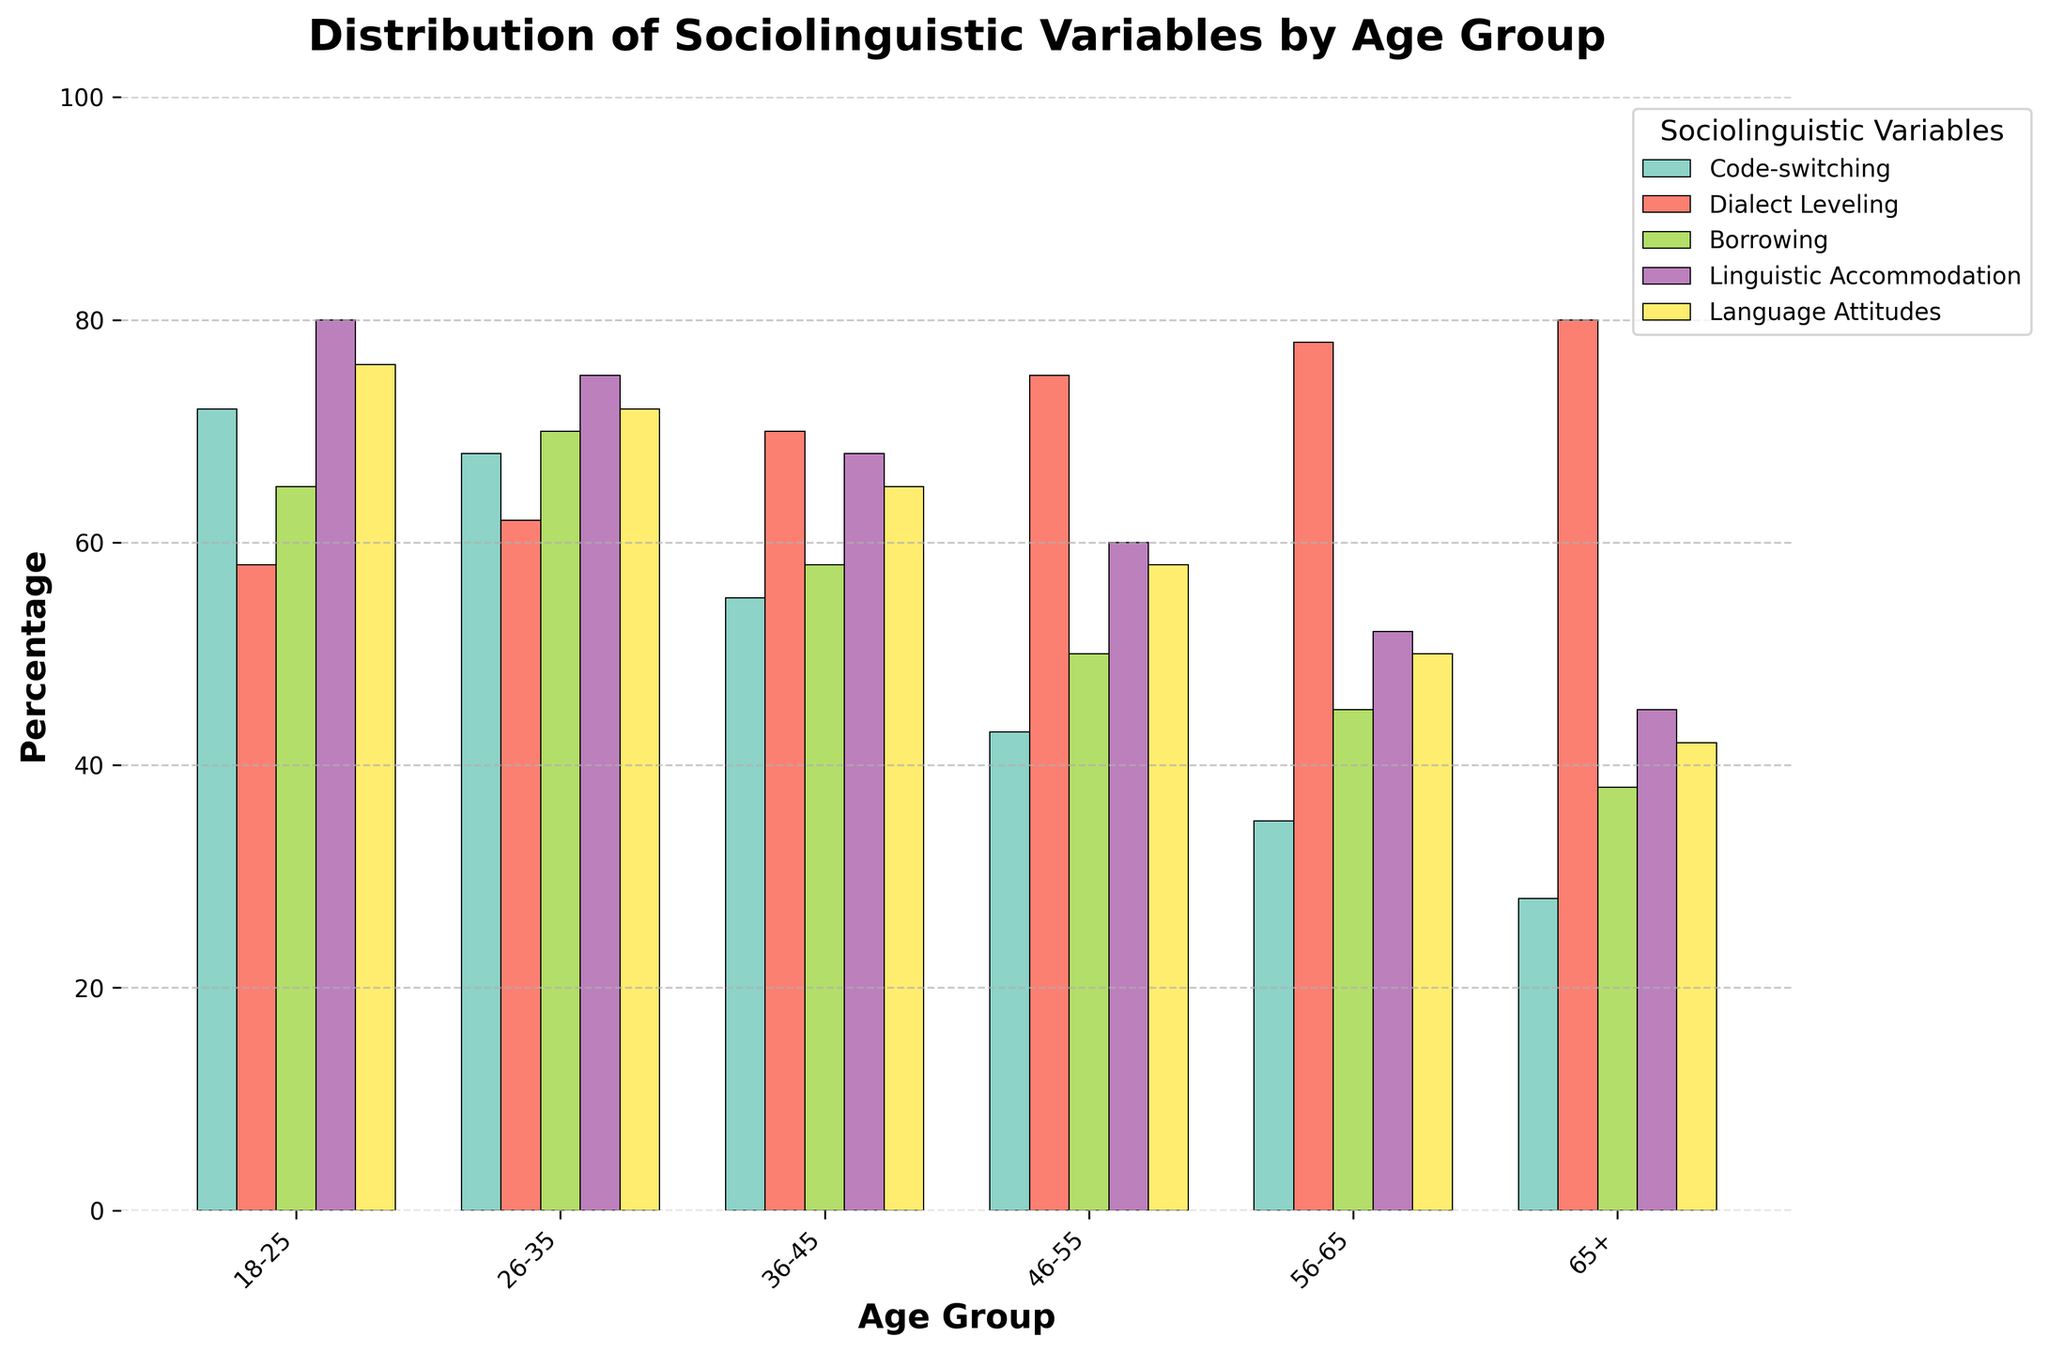Which age group has the highest percentage of linguistic accommodation? The tallest bar in the Linguistic Accommodation category corresponds to the 18-25 age group.
Answer: 18-25 Which sociolinguistic variable shows a steady increase with age group? By observing the chart, borrowing shows a general downward trend across age groups, indicating the opposite. Dialect Leveling shows a gradual increase as age increases.
Answer: Dialect Leveling What is the difference in percentage of code-switching between the 18-25 and 56-65 age groups? The 18-25 age group has 72% for code-switching, while the 56-65 age group has 35%. The difference is 72 - 35 = 37.
Answer: 37 Which age group has the least positive language attitudes, and what is that percentage? The shortest bar in the Language Attitudes variable is in the 65+ category, which corresponds to 42%.
Answer: 65+, 42 How does the percentage of dialect leveling change from the 18-25 age group to the 65+ age group? The percentage of Dialect Leveling for 18-25 is 58%, and for 65+ it's 80%. This is an increase of 80 - 58 = 22.
Answer: Increases by 22 Is there an age group where borrowing exceeds code-switching? In the 46-55, 56-65, and 65+ age groups, the percentage of borrowing is lower than code-switching.
Answer: No What is the average percentage of linguistic accommodation across all age groups? Sum the percentages: 80 + 75 + 68 + 60 + 52 + 45 = 380. There are 6 age groups, so the average is 380 / 6 ≈ 63.33.
Answer: 63.33 Compare the percentage of language attitudes between the 36-45 and 46-55 age groups. Who has a higher percentage and by how much? The 36-45 age group has 65%, and the 46-55 age group has 58%. The difference is 65 - 58 = 7, so the 36-45 age group is higher by 7.
Answer: 36-45, higher by 7 